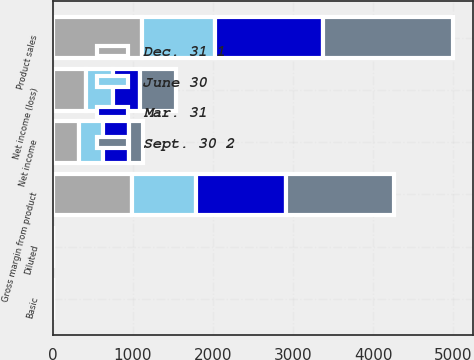Convert chart. <chart><loc_0><loc_0><loc_500><loc_500><stacked_bar_chart><ecel><fcel>Product sales<fcel>Gross margin from product<fcel>Net income (loss)<fcel>Basic<fcel>Diluted<fcel>Net income<nl><fcel>Sept. 30 2<fcel>1621.6<fcel>1347.8<fcel>456.4<fcel>0.35<fcel>0.34<fcel>163<nl><fcel>Mar. 31<fcel>1345.8<fcel>1119.4<fcel>329.9<fcel>2.1<fcel>2.1<fcel>329.9<nl><fcel>Dec. 31 1<fcel>1115.2<fcel>983.3<fcel>412.4<fcel>0.4<fcel>0.38<fcel>321.9<nl><fcel>June 30<fcel>908.6<fcel>805<fcel>340.9<fcel>0.33<fcel>0.32<fcel>304.9<nl></chart> 